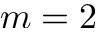Convert formula to latex. <formula><loc_0><loc_0><loc_500><loc_500>m = 2</formula> 